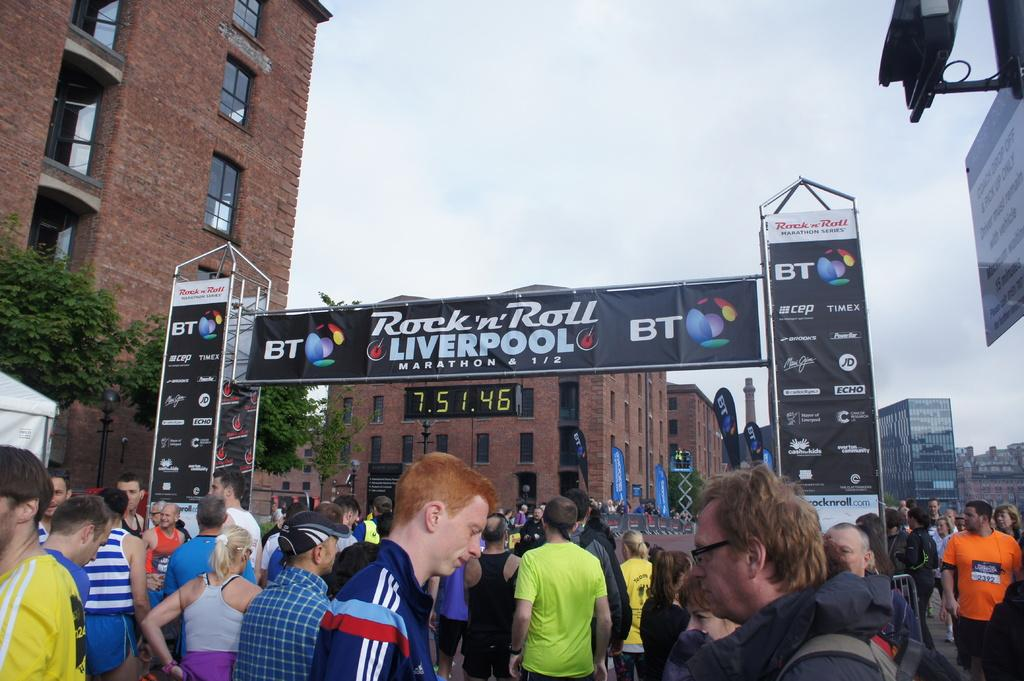<image>
Summarize the visual content of the image. A group of people are at a Rock'n' Roll Liverpool MARATHON series, with advertisements on the side including TIMEX and Echo. 